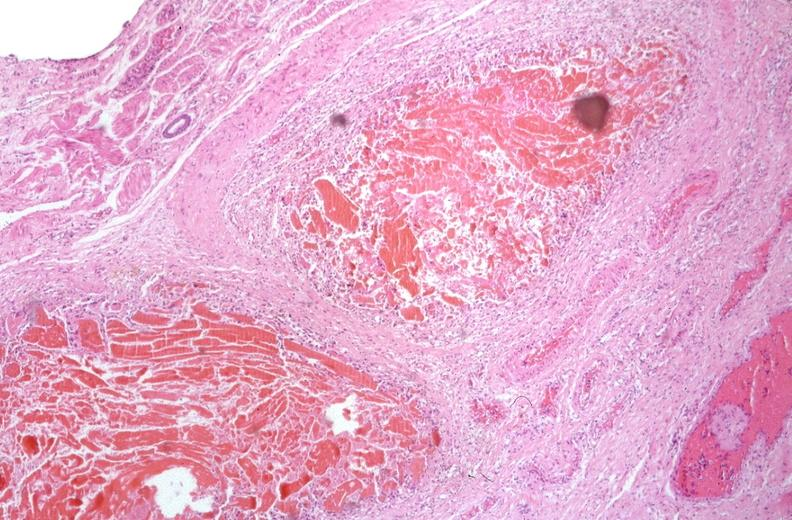what is present?
Answer the question using a single word or phrase. Gastrointestinal 